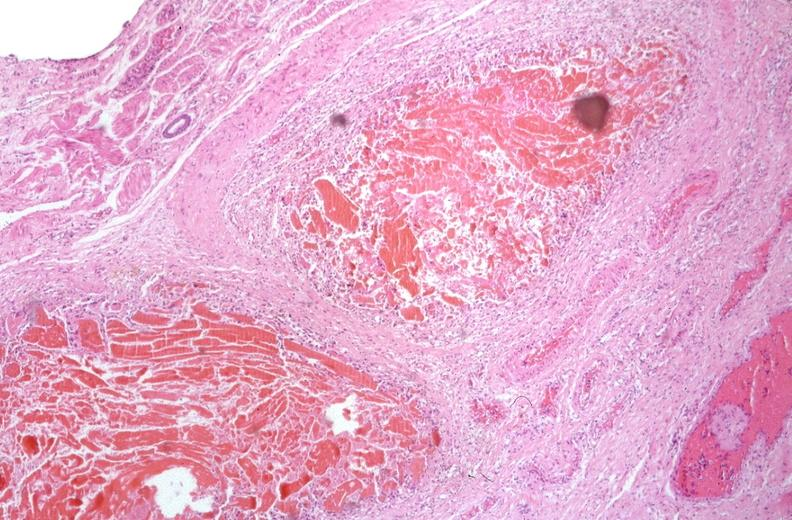what is present?
Answer the question using a single word or phrase. Gastrointestinal 